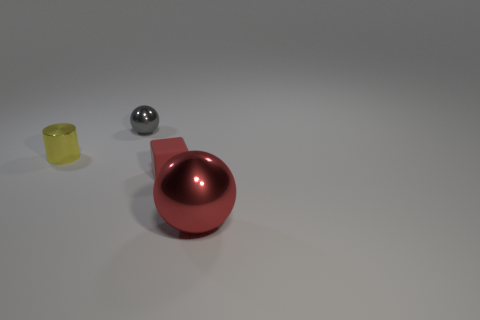What size is the gray shiny ball? The gray ball appears to be relatively small in size, likely no larger than a standard ping-pong ball when compared to objects around it which provide some context for scale. 